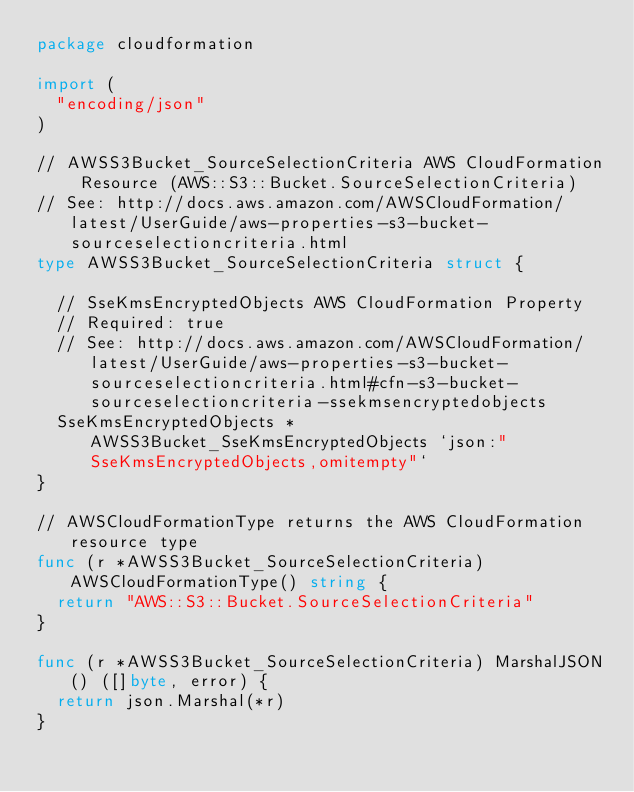Convert code to text. <code><loc_0><loc_0><loc_500><loc_500><_Go_>package cloudformation

import (
	"encoding/json"
)

// AWSS3Bucket_SourceSelectionCriteria AWS CloudFormation Resource (AWS::S3::Bucket.SourceSelectionCriteria)
// See: http://docs.aws.amazon.com/AWSCloudFormation/latest/UserGuide/aws-properties-s3-bucket-sourceselectioncriteria.html
type AWSS3Bucket_SourceSelectionCriteria struct {

	// SseKmsEncryptedObjects AWS CloudFormation Property
	// Required: true
	// See: http://docs.aws.amazon.com/AWSCloudFormation/latest/UserGuide/aws-properties-s3-bucket-sourceselectioncriteria.html#cfn-s3-bucket-sourceselectioncriteria-ssekmsencryptedobjects
	SseKmsEncryptedObjects *AWSS3Bucket_SseKmsEncryptedObjects `json:"SseKmsEncryptedObjects,omitempty"`
}

// AWSCloudFormationType returns the AWS CloudFormation resource type
func (r *AWSS3Bucket_SourceSelectionCriteria) AWSCloudFormationType() string {
	return "AWS::S3::Bucket.SourceSelectionCriteria"
}

func (r *AWSS3Bucket_SourceSelectionCriteria) MarshalJSON() ([]byte, error) {
	return json.Marshal(*r)
}
</code> 